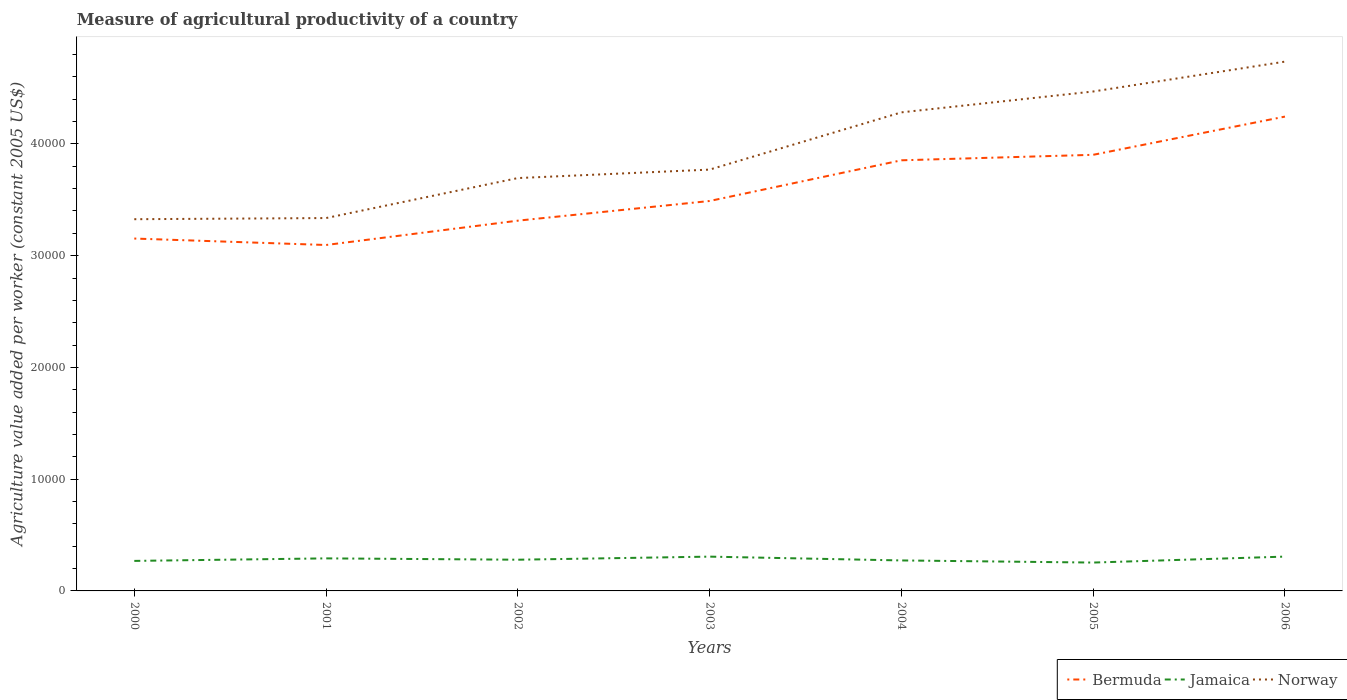How many different coloured lines are there?
Your answer should be very brief. 3. Across all years, what is the maximum measure of agricultural productivity in Jamaica?
Ensure brevity in your answer.  2537.5. In which year was the measure of agricultural productivity in Bermuda maximum?
Give a very brief answer. 2001. What is the total measure of agricultural productivity in Jamaica in the graph?
Give a very brief answer. -533.72. What is the difference between the highest and the second highest measure of agricultural productivity in Bermuda?
Your response must be concise. 1.15e+04. How many years are there in the graph?
Your answer should be very brief. 7. What is the difference between two consecutive major ticks on the Y-axis?
Ensure brevity in your answer.  10000. Are the values on the major ticks of Y-axis written in scientific E-notation?
Make the answer very short. No. Where does the legend appear in the graph?
Provide a succinct answer. Bottom right. How many legend labels are there?
Give a very brief answer. 3. How are the legend labels stacked?
Your response must be concise. Horizontal. What is the title of the graph?
Your response must be concise. Measure of agricultural productivity of a country. Does "Sierra Leone" appear as one of the legend labels in the graph?
Provide a short and direct response. No. What is the label or title of the Y-axis?
Your answer should be very brief. Agriculture value added per worker (constant 2005 US$). What is the Agriculture value added per worker (constant 2005 US$) in Bermuda in 2000?
Give a very brief answer. 3.15e+04. What is the Agriculture value added per worker (constant 2005 US$) in Jamaica in 2000?
Your answer should be very brief. 2686.01. What is the Agriculture value added per worker (constant 2005 US$) in Norway in 2000?
Your response must be concise. 3.33e+04. What is the Agriculture value added per worker (constant 2005 US$) in Bermuda in 2001?
Offer a terse response. 3.10e+04. What is the Agriculture value added per worker (constant 2005 US$) of Jamaica in 2001?
Your response must be concise. 2912.46. What is the Agriculture value added per worker (constant 2005 US$) of Norway in 2001?
Offer a very short reply. 3.34e+04. What is the Agriculture value added per worker (constant 2005 US$) of Bermuda in 2002?
Your answer should be compact. 3.31e+04. What is the Agriculture value added per worker (constant 2005 US$) of Jamaica in 2002?
Provide a succinct answer. 2793.05. What is the Agriculture value added per worker (constant 2005 US$) of Norway in 2002?
Offer a very short reply. 3.69e+04. What is the Agriculture value added per worker (constant 2005 US$) of Bermuda in 2003?
Your answer should be very brief. 3.49e+04. What is the Agriculture value added per worker (constant 2005 US$) of Jamaica in 2003?
Give a very brief answer. 3068.65. What is the Agriculture value added per worker (constant 2005 US$) in Norway in 2003?
Your answer should be very brief. 3.77e+04. What is the Agriculture value added per worker (constant 2005 US$) of Bermuda in 2004?
Offer a terse response. 3.85e+04. What is the Agriculture value added per worker (constant 2005 US$) of Jamaica in 2004?
Make the answer very short. 2727.81. What is the Agriculture value added per worker (constant 2005 US$) of Norway in 2004?
Your response must be concise. 4.28e+04. What is the Agriculture value added per worker (constant 2005 US$) of Bermuda in 2005?
Give a very brief answer. 3.90e+04. What is the Agriculture value added per worker (constant 2005 US$) in Jamaica in 2005?
Keep it short and to the point. 2537.5. What is the Agriculture value added per worker (constant 2005 US$) in Norway in 2005?
Keep it short and to the point. 4.47e+04. What is the Agriculture value added per worker (constant 2005 US$) in Bermuda in 2006?
Ensure brevity in your answer.  4.24e+04. What is the Agriculture value added per worker (constant 2005 US$) in Jamaica in 2006?
Provide a succinct answer. 3071.22. What is the Agriculture value added per worker (constant 2005 US$) of Norway in 2006?
Provide a succinct answer. 4.74e+04. Across all years, what is the maximum Agriculture value added per worker (constant 2005 US$) of Bermuda?
Offer a terse response. 4.24e+04. Across all years, what is the maximum Agriculture value added per worker (constant 2005 US$) of Jamaica?
Ensure brevity in your answer.  3071.22. Across all years, what is the maximum Agriculture value added per worker (constant 2005 US$) of Norway?
Provide a short and direct response. 4.74e+04. Across all years, what is the minimum Agriculture value added per worker (constant 2005 US$) in Bermuda?
Offer a very short reply. 3.10e+04. Across all years, what is the minimum Agriculture value added per worker (constant 2005 US$) in Jamaica?
Give a very brief answer. 2537.5. Across all years, what is the minimum Agriculture value added per worker (constant 2005 US$) in Norway?
Provide a short and direct response. 3.33e+04. What is the total Agriculture value added per worker (constant 2005 US$) in Bermuda in the graph?
Make the answer very short. 2.51e+05. What is the total Agriculture value added per worker (constant 2005 US$) in Jamaica in the graph?
Keep it short and to the point. 1.98e+04. What is the total Agriculture value added per worker (constant 2005 US$) of Norway in the graph?
Your response must be concise. 2.76e+05. What is the difference between the Agriculture value added per worker (constant 2005 US$) of Bermuda in 2000 and that in 2001?
Your answer should be compact. 577.34. What is the difference between the Agriculture value added per worker (constant 2005 US$) in Jamaica in 2000 and that in 2001?
Your answer should be compact. -226.46. What is the difference between the Agriculture value added per worker (constant 2005 US$) in Norway in 2000 and that in 2001?
Give a very brief answer. -102.81. What is the difference between the Agriculture value added per worker (constant 2005 US$) in Bermuda in 2000 and that in 2002?
Provide a succinct answer. -1600.27. What is the difference between the Agriculture value added per worker (constant 2005 US$) of Jamaica in 2000 and that in 2002?
Give a very brief answer. -107.04. What is the difference between the Agriculture value added per worker (constant 2005 US$) in Norway in 2000 and that in 2002?
Your answer should be compact. -3681.59. What is the difference between the Agriculture value added per worker (constant 2005 US$) of Bermuda in 2000 and that in 2003?
Keep it short and to the point. -3360.66. What is the difference between the Agriculture value added per worker (constant 2005 US$) of Jamaica in 2000 and that in 2003?
Make the answer very short. -382.64. What is the difference between the Agriculture value added per worker (constant 2005 US$) in Norway in 2000 and that in 2003?
Make the answer very short. -4439.3. What is the difference between the Agriculture value added per worker (constant 2005 US$) in Bermuda in 2000 and that in 2004?
Give a very brief answer. -7002.21. What is the difference between the Agriculture value added per worker (constant 2005 US$) of Jamaica in 2000 and that in 2004?
Ensure brevity in your answer.  -41.8. What is the difference between the Agriculture value added per worker (constant 2005 US$) of Norway in 2000 and that in 2004?
Provide a short and direct response. -9561.19. What is the difference between the Agriculture value added per worker (constant 2005 US$) of Bermuda in 2000 and that in 2005?
Offer a very short reply. -7493.55. What is the difference between the Agriculture value added per worker (constant 2005 US$) in Jamaica in 2000 and that in 2005?
Make the answer very short. 148.5. What is the difference between the Agriculture value added per worker (constant 2005 US$) of Norway in 2000 and that in 2005?
Provide a succinct answer. -1.14e+04. What is the difference between the Agriculture value added per worker (constant 2005 US$) in Bermuda in 2000 and that in 2006?
Ensure brevity in your answer.  -1.09e+04. What is the difference between the Agriculture value added per worker (constant 2005 US$) in Jamaica in 2000 and that in 2006?
Your answer should be compact. -385.21. What is the difference between the Agriculture value added per worker (constant 2005 US$) of Norway in 2000 and that in 2006?
Offer a terse response. -1.41e+04. What is the difference between the Agriculture value added per worker (constant 2005 US$) of Bermuda in 2001 and that in 2002?
Make the answer very short. -2177.61. What is the difference between the Agriculture value added per worker (constant 2005 US$) of Jamaica in 2001 and that in 2002?
Provide a short and direct response. 119.42. What is the difference between the Agriculture value added per worker (constant 2005 US$) of Norway in 2001 and that in 2002?
Offer a terse response. -3578.77. What is the difference between the Agriculture value added per worker (constant 2005 US$) of Bermuda in 2001 and that in 2003?
Provide a short and direct response. -3938. What is the difference between the Agriculture value added per worker (constant 2005 US$) of Jamaica in 2001 and that in 2003?
Provide a succinct answer. -156.18. What is the difference between the Agriculture value added per worker (constant 2005 US$) in Norway in 2001 and that in 2003?
Your answer should be very brief. -4336.49. What is the difference between the Agriculture value added per worker (constant 2005 US$) of Bermuda in 2001 and that in 2004?
Offer a very short reply. -7579.55. What is the difference between the Agriculture value added per worker (constant 2005 US$) in Jamaica in 2001 and that in 2004?
Your answer should be very brief. 184.66. What is the difference between the Agriculture value added per worker (constant 2005 US$) in Norway in 2001 and that in 2004?
Offer a terse response. -9458.38. What is the difference between the Agriculture value added per worker (constant 2005 US$) in Bermuda in 2001 and that in 2005?
Ensure brevity in your answer.  -8070.89. What is the difference between the Agriculture value added per worker (constant 2005 US$) in Jamaica in 2001 and that in 2005?
Provide a succinct answer. 374.96. What is the difference between the Agriculture value added per worker (constant 2005 US$) of Norway in 2001 and that in 2005?
Ensure brevity in your answer.  -1.13e+04. What is the difference between the Agriculture value added per worker (constant 2005 US$) in Bermuda in 2001 and that in 2006?
Keep it short and to the point. -1.15e+04. What is the difference between the Agriculture value added per worker (constant 2005 US$) in Jamaica in 2001 and that in 2006?
Offer a very short reply. -158.76. What is the difference between the Agriculture value added per worker (constant 2005 US$) in Norway in 2001 and that in 2006?
Offer a terse response. -1.40e+04. What is the difference between the Agriculture value added per worker (constant 2005 US$) in Bermuda in 2002 and that in 2003?
Offer a terse response. -1760.39. What is the difference between the Agriculture value added per worker (constant 2005 US$) in Jamaica in 2002 and that in 2003?
Provide a succinct answer. -275.6. What is the difference between the Agriculture value added per worker (constant 2005 US$) of Norway in 2002 and that in 2003?
Provide a short and direct response. -757.71. What is the difference between the Agriculture value added per worker (constant 2005 US$) in Bermuda in 2002 and that in 2004?
Your answer should be compact. -5401.94. What is the difference between the Agriculture value added per worker (constant 2005 US$) in Jamaica in 2002 and that in 2004?
Keep it short and to the point. 65.24. What is the difference between the Agriculture value added per worker (constant 2005 US$) in Norway in 2002 and that in 2004?
Offer a very short reply. -5879.61. What is the difference between the Agriculture value added per worker (constant 2005 US$) of Bermuda in 2002 and that in 2005?
Keep it short and to the point. -5893.28. What is the difference between the Agriculture value added per worker (constant 2005 US$) of Jamaica in 2002 and that in 2005?
Your answer should be compact. 255.54. What is the difference between the Agriculture value added per worker (constant 2005 US$) in Norway in 2002 and that in 2005?
Give a very brief answer. -7746.68. What is the difference between the Agriculture value added per worker (constant 2005 US$) in Bermuda in 2002 and that in 2006?
Make the answer very short. -9312.49. What is the difference between the Agriculture value added per worker (constant 2005 US$) of Jamaica in 2002 and that in 2006?
Your response must be concise. -278.17. What is the difference between the Agriculture value added per worker (constant 2005 US$) in Norway in 2002 and that in 2006?
Make the answer very short. -1.04e+04. What is the difference between the Agriculture value added per worker (constant 2005 US$) of Bermuda in 2003 and that in 2004?
Make the answer very short. -3641.55. What is the difference between the Agriculture value added per worker (constant 2005 US$) in Jamaica in 2003 and that in 2004?
Provide a succinct answer. 340.84. What is the difference between the Agriculture value added per worker (constant 2005 US$) in Norway in 2003 and that in 2004?
Offer a very short reply. -5121.89. What is the difference between the Agriculture value added per worker (constant 2005 US$) in Bermuda in 2003 and that in 2005?
Your answer should be compact. -4132.89. What is the difference between the Agriculture value added per worker (constant 2005 US$) of Jamaica in 2003 and that in 2005?
Your response must be concise. 531.14. What is the difference between the Agriculture value added per worker (constant 2005 US$) of Norway in 2003 and that in 2005?
Your answer should be very brief. -6988.97. What is the difference between the Agriculture value added per worker (constant 2005 US$) of Bermuda in 2003 and that in 2006?
Make the answer very short. -7552.1. What is the difference between the Agriculture value added per worker (constant 2005 US$) of Jamaica in 2003 and that in 2006?
Keep it short and to the point. -2.57. What is the difference between the Agriculture value added per worker (constant 2005 US$) in Norway in 2003 and that in 2006?
Your answer should be compact. -9661.74. What is the difference between the Agriculture value added per worker (constant 2005 US$) of Bermuda in 2004 and that in 2005?
Offer a very short reply. -491.34. What is the difference between the Agriculture value added per worker (constant 2005 US$) of Jamaica in 2004 and that in 2005?
Your answer should be compact. 190.31. What is the difference between the Agriculture value added per worker (constant 2005 US$) of Norway in 2004 and that in 2005?
Provide a succinct answer. -1867.08. What is the difference between the Agriculture value added per worker (constant 2005 US$) in Bermuda in 2004 and that in 2006?
Make the answer very short. -3910.55. What is the difference between the Agriculture value added per worker (constant 2005 US$) in Jamaica in 2004 and that in 2006?
Provide a short and direct response. -343.41. What is the difference between the Agriculture value added per worker (constant 2005 US$) in Norway in 2004 and that in 2006?
Your answer should be compact. -4539.85. What is the difference between the Agriculture value added per worker (constant 2005 US$) in Bermuda in 2005 and that in 2006?
Your answer should be very brief. -3419.22. What is the difference between the Agriculture value added per worker (constant 2005 US$) of Jamaica in 2005 and that in 2006?
Offer a terse response. -533.72. What is the difference between the Agriculture value added per worker (constant 2005 US$) of Norway in 2005 and that in 2006?
Offer a very short reply. -2672.77. What is the difference between the Agriculture value added per worker (constant 2005 US$) in Bermuda in 2000 and the Agriculture value added per worker (constant 2005 US$) in Jamaica in 2001?
Provide a succinct answer. 2.86e+04. What is the difference between the Agriculture value added per worker (constant 2005 US$) in Bermuda in 2000 and the Agriculture value added per worker (constant 2005 US$) in Norway in 2001?
Offer a very short reply. -1833.43. What is the difference between the Agriculture value added per worker (constant 2005 US$) of Jamaica in 2000 and the Agriculture value added per worker (constant 2005 US$) of Norway in 2001?
Give a very brief answer. -3.07e+04. What is the difference between the Agriculture value added per worker (constant 2005 US$) of Bermuda in 2000 and the Agriculture value added per worker (constant 2005 US$) of Jamaica in 2002?
Provide a short and direct response. 2.87e+04. What is the difference between the Agriculture value added per worker (constant 2005 US$) of Bermuda in 2000 and the Agriculture value added per worker (constant 2005 US$) of Norway in 2002?
Offer a very short reply. -5412.21. What is the difference between the Agriculture value added per worker (constant 2005 US$) in Jamaica in 2000 and the Agriculture value added per worker (constant 2005 US$) in Norway in 2002?
Your response must be concise. -3.43e+04. What is the difference between the Agriculture value added per worker (constant 2005 US$) of Bermuda in 2000 and the Agriculture value added per worker (constant 2005 US$) of Jamaica in 2003?
Offer a very short reply. 2.85e+04. What is the difference between the Agriculture value added per worker (constant 2005 US$) of Bermuda in 2000 and the Agriculture value added per worker (constant 2005 US$) of Norway in 2003?
Your answer should be compact. -6169.92. What is the difference between the Agriculture value added per worker (constant 2005 US$) of Jamaica in 2000 and the Agriculture value added per worker (constant 2005 US$) of Norway in 2003?
Your response must be concise. -3.50e+04. What is the difference between the Agriculture value added per worker (constant 2005 US$) of Bermuda in 2000 and the Agriculture value added per worker (constant 2005 US$) of Jamaica in 2004?
Make the answer very short. 2.88e+04. What is the difference between the Agriculture value added per worker (constant 2005 US$) in Bermuda in 2000 and the Agriculture value added per worker (constant 2005 US$) in Norway in 2004?
Provide a short and direct response. -1.13e+04. What is the difference between the Agriculture value added per worker (constant 2005 US$) of Jamaica in 2000 and the Agriculture value added per worker (constant 2005 US$) of Norway in 2004?
Make the answer very short. -4.01e+04. What is the difference between the Agriculture value added per worker (constant 2005 US$) in Bermuda in 2000 and the Agriculture value added per worker (constant 2005 US$) in Jamaica in 2005?
Your answer should be compact. 2.90e+04. What is the difference between the Agriculture value added per worker (constant 2005 US$) of Bermuda in 2000 and the Agriculture value added per worker (constant 2005 US$) of Norway in 2005?
Offer a very short reply. -1.32e+04. What is the difference between the Agriculture value added per worker (constant 2005 US$) of Jamaica in 2000 and the Agriculture value added per worker (constant 2005 US$) of Norway in 2005?
Offer a terse response. -4.20e+04. What is the difference between the Agriculture value added per worker (constant 2005 US$) of Bermuda in 2000 and the Agriculture value added per worker (constant 2005 US$) of Jamaica in 2006?
Keep it short and to the point. 2.85e+04. What is the difference between the Agriculture value added per worker (constant 2005 US$) in Bermuda in 2000 and the Agriculture value added per worker (constant 2005 US$) in Norway in 2006?
Keep it short and to the point. -1.58e+04. What is the difference between the Agriculture value added per worker (constant 2005 US$) of Jamaica in 2000 and the Agriculture value added per worker (constant 2005 US$) of Norway in 2006?
Give a very brief answer. -4.47e+04. What is the difference between the Agriculture value added per worker (constant 2005 US$) in Bermuda in 2001 and the Agriculture value added per worker (constant 2005 US$) in Jamaica in 2002?
Keep it short and to the point. 2.82e+04. What is the difference between the Agriculture value added per worker (constant 2005 US$) of Bermuda in 2001 and the Agriculture value added per worker (constant 2005 US$) of Norway in 2002?
Offer a terse response. -5989.55. What is the difference between the Agriculture value added per worker (constant 2005 US$) of Jamaica in 2001 and the Agriculture value added per worker (constant 2005 US$) of Norway in 2002?
Keep it short and to the point. -3.40e+04. What is the difference between the Agriculture value added per worker (constant 2005 US$) in Bermuda in 2001 and the Agriculture value added per worker (constant 2005 US$) in Jamaica in 2003?
Keep it short and to the point. 2.79e+04. What is the difference between the Agriculture value added per worker (constant 2005 US$) of Bermuda in 2001 and the Agriculture value added per worker (constant 2005 US$) of Norway in 2003?
Your answer should be very brief. -6747.26. What is the difference between the Agriculture value added per worker (constant 2005 US$) in Jamaica in 2001 and the Agriculture value added per worker (constant 2005 US$) in Norway in 2003?
Your response must be concise. -3.48e+04. What is the difference between the Agriculture value added per worker (constant 2005 US$) of Bermuda in 2001 and the Agriculture value added per worker (constant 2005 US$) of Jamaica in 2004?
Your response must be concise. 2.82e+04. What is the difference between the Agriculture value added per worker (constant 2005 US$) of Bermuda in 2001 and the Agriculture value added per worker (constant 2005 US$) of Norway in 2004?
Your answer should be very brief. -1.19e+04. What is the difference between the Agriculture value added per worker (constant 2005 US$) in Jamaica in 2001 and the Agriculture value added per worker (constant 2005 US$) in Norway in 2004?
Your answer should be compact. -3.99e+04. What is the difference between the Agriculture value added per worker (constant 2005 US$) in Bermuda in 2001 and the Agriculture value added per worker (constant 2005 US$) in Jamaica in 2005?
Your response must be concise. 2.84e+04. What is the difference between the Agriculture value added per worker (constant 2005 US$) in Bermuda in 2001 and the Agriculture value added per worker (constant 2005 US$) in Norway in 2005?
Offer a terse response. -1.37e+04. What is the difference between the Agriculture value added per worker (constant 2005 US$) in Jamaica in 2001 and the Agriculture value added per worker (constant 2005 US$) in Norway in 2005?
Offer a very short reply. -4.18e+04. What is the difference between the Agriculture value added per worker (constant 2005 US$) of Bermuda in 2001 and the Agriculture value added per worker (constant 2005 US$) of Jamaica in 2006?
Offer a terse response. 2.79e+04. What is the difference between the Agriculture value added per worker (constant 2005 US$) in Bermuda in 2001 and the Agriculture value added per worker (constant 2005 US$) in Norway in 2006?
Your response must be concise. -1.64e+04. What is the difference between the Agriculture value added per worker (constant 2005 US$) in Jamaica in 2001 and the Agriculture value added per worker (constant 2005 US$) in Norway in 2006?
Keep it short and to the point. -4.45e+04. What is the difference between the Agriculture value added per worker (constant 2005 US$) in Bermuda in 2002 and the Agriculture value added per worker (constant 2005 US$) in Jamaica in 2003?
Offer a terse response. 3.01e+04. What is the difference between the Agriculture value added per worker (constant 2005 US$) of Bermuda in 2002 and the Agriculture value added per worker (constant 2005 US$) of Norway in 2003?
Keep it short and to the point. -4569.65. What is the difference between the Agriculture value added per worker (constant 2005 US$) of Jamaica in 2002 and the Agriculture value added per worker (constant 2005 US$) of Norway in 2003?
Offer a very short reply. -3.49e+04. What is the difference between the Agriculture value added per worker (constant 2005 US$) of Bermuda in 2002 and the Agriculture value added per worker (constant 2005 US$) of Jamaica in 2004?
Provide a short and direct response. 3.04e+04. What is the difference between the Agriculture value added per worker (constant 2005 US$) in Bermuda in 2002 and the Agriculture value added per worker (constant 2005 US$) in Norway in 2004?
Your answer should be very brief. -9691.54. What is the difference between the Agriculture value added per worker (constant 2005 US$) of Jamaica in 2002 and the Agriculture value added per worker (constant 2005 US$) of Norway in 2004?
Your answer should be compact. -4.00e+04. What is the difference between the Agriculture value added per worker (constant 2005 US$) in Bermuda in 2002 and the Agriculture value added per worker (constant 2005 US$) in Jamaica in 2005?
Your answer should be compact. 3.06e+04. What is the difference between the Agriculture value added per worker (constant 2005 US$) in Bermuda in 2002 and the Agriculture value added per worker (constant 2005 US$) in Norway in 2005?
Ensure brevity in your answer.  -1.16e+04. What is the difference between the Agriculture value added per worker (constant 2005 US$) of Jamaica in 2002 and the Agriculture value added per worker (constant 2005 US$) of Norway in 2005?
Your response must be concise. -4.19e+04. What is the difference between the Agriculture value added per worker (constant 2005 US$) of Bermuda in 2002 and the Agriculture value added per worker (constant 2005 US$) of Jamaica in 2006?
Your answer should be very brief. 3.01e+04. What is the difference between the Agriculture value added per worker (constant 2005 US$) of Bermuda in 2002 and the Agriculture value added per worker (constant 2005 US$) of Norway in 2006?
Ensure brevity in your answer.  -1.42e+04. What is the difference between the Agriculture value added per worker (constant 2005 US$) of Jamaica in 2002 and the Agriculture value added per worker (constant 2005 US$) of Norway in 2006?
Offer a very short reply. -4.46e+04. What is the difference between the Agriculture value added per worker (constant 2005 US$) in Bermuda in 2003 and the Agriculture value added per worker (constant 2005 US$) in Jamaica in 2004?
Provide a succinct answer. 3.22e+04. What is the difference between the Agriculture value added per worker (constant 2005 US$) in Bermuda in 2003 and the Agriculture value added per worker (constant 2005 US$) in Norway in 2004?
Provide a succinct answer. -7931.15. What is the difference between the Agriculture value added per worker (constant 2005 US$) in Jamaica in 2003 and the Agriculture value added per worker (constant 2005 US$) in Norway in 2004?
Provide a succinct answer. -3.98e+04. What is the difference between the Agriculture value added per worker (constant 2005 US$) of Bermuda in 2003 and the Agriculture value added per worker (constant 2005 US$) of Jamaica in 2005?
Provide a short and direct response. 3.24e+04. What is the difference between the Agriculture value added per worker (constant 2005 US$) of Bermuda in 2003 and the Agriculture value added per worker (constant 2005 US$) of Norway in 2005?
Provide a succinct answer. -9798.23. What is the difference between the Agriculture value added per worker (constant 2005 US$) of Jamaica in 2003 and the Agriculture value added per worker (constant 2005 US$) of Norway in 2005?
Make the answer very short. -4.16e+04. What is the difference between the Agriculture value added per worker (constant 2005 US$) of Bermuda in 2003 and the Agriculture value added per worker (constant 2005 US$) of Jamaica in 2006?
Give a very brief answer. 3.18e+04. What is the difference between the Agriculture value added per worker (constant 2005 US$) in Bermuda in 2003 and the Agriculture value added per worker (constant 2005 US$) in Norway in 2006?
Your answer should be compact. -1.25e+04. What is the difference between the Agriculture value added per worker (constant 2005 US$) in Jamaica in 2003 and the Agriculture value added per worker (constant 2005 US$) in Norway in 2006?
Your answer should be compact. -4.43e+04. What is the difference between the Agriculture value added per worker (constant 2005 US$) of Bermuda in 2004 and the Agriculture value added per worker (constant 2005 US$) of Jamaica in 2005?
Your answer should be very brief. 3.60e+04. What is the difference between the Agriculture value added per worker (constant 2005 US$) of Bermuda in 2004 and the Agriculture value added per worker (constant 2005 US$) of Norway in 2005?
Provide a succinct answer. -6156.68. What is the difference between the Agriculture value added per worker (constant 2005 US$) in Jamaica in 2004 and the Agriculture value added per worker (constant 2005 US$) in Norway in 2005?
Your answer should be very brief. -4.20e+04. What is the difference between the Agriculture value added per worker (constant 2005 US$) in Bermuda in 2004 and the Agriculture value added per worker (constant 2005 US$) in Jamaica in 2006?
Offer a very short reply. 3.55e+04. What is the difference between the Agriculture value added per worker (constant 2005 US$) in Bermuda in 2004 and the Agriculture value added per worker (constant 2005 US$) in Norway in 2006?
Give a very brief answer. -8829.45. What is the difference between the Agriculture value added per worker (constant 2005 US$) of Jamaica in 2004 and the Agriculture value added per worker (constant 2005 US$) of Norway in 2006?
Offer a very short reply. -4.46e+04. What is the difference between the Agriculture value added per worker (constant 2005 US$) in Bermuda in 2005 and the Agriculture value added per worker (constant 2005 US$) in Jamaica in 2006?
Your answer should be compact. 3.60e+04. What is the difference between the Agriculture value added per worker (constant 2005 US$) in Bermuda in 2005 and the Agriculture value added per worker (constant 2005 US$) in Norway in 2006?
Your answer should be compact. -8338.11. What is the difference between the Agriculture value added per worker (constant 2005 US$) of Jamaica in 2005 and the Agriculture value added per worker (constant 2005 US$) of Norway in 2006?
Make the answer very short. -4.48e+04. What is the average Agriculture value added per worker (constant 2005 US$) in Bermuda per year?
Keep it short and to the point. 3.58e+04. What is the average Agriculture value added per worker (constant 2005 US$) of Jamaica per year?
Your answer should be compact. 2828.1. What is the average Agriculture value added per worker (constant 2005 US$) of Norway per year?
Offer a terse response. 3.94e+04. In the year 2000, what is the difference between the Agriculture value added per worker (constant 2005 US$) of Bermuda and Agriculture value added per worker (constant 2005 US$) of Jamaica?
Your response must be concise. 2.88e+04. In the year 2000, what is the difference between the Agriculture value added per worker (constant 2005 US$) of Bermuda and Agriculture value added per worker (constant 2005 US$) of Norway?
Provide a short and direct response. -1730.62. In the year 2000, what is the difference between the Agriculture value added per worker (constant 2005 US$) of Jamaica and Agriculture value added per worker (constant 2005 US$) of Norway?
Your response must be concise. -3.06e+04. In the year 2001, what is the difference between the Agriculture value added per worker (constant 2005 US$) in Bermuda and Agriculture value added per worker (constant 2005 US$) in Jamaica?
Give a very brief answer. 2.80e+04. In the year 2001, what is the difference between the Agriculture value added per worker (constant 2005 US$) of Bermuda and Agriculture value added per worker (constant 2005 US$) of Norway?
Your response must be concise. -2410.77. In the year 2001, what is the difference between the Agriculture value added per worker (constant 2005 US$) of Jamaica and Agriculture value added per worker (constant 2005 US$) of Norway?
Provide a succinct answer. -3.05e+04. In the year 2002, what is the difference between the Agriculture value added per worker (constant 2005 US$) of Bermuda and Agriculture value added per worker (constant 2005 US$) of Jamaica?
Make the answer very short. 3.03e+04. In the year 2002, what is the difference between the Agriculture value added per worker (constant 2005 US$) of Bermuda and Agriculture value added per worker (constant 2005 US$) of Norway?
Your answer should be compact. -3811.94. In the year 2002, what is the difference between the Agriculture value added per worker (constant 2005 US$) of Jamaica and Agriculture value added per worker (constant 2005 US$) of Norway?
Your answer should be very brief. -3.42e+04. In the year 2003, what is the difference between the Agriculture value added per worker (constant 2005 US$) of Bermuda and Agriculture value added per worker (constant 2005 US$) of Jamaica?
Give a very brief answer. 3.18e+04. In the year 2003, what is the difference between the Agriculture value added per worker (constant 2005 US$) in Bermuda and Agriculture value added per worker (constant 2005 US$) in Norway?
Give a very brief answer. -2809.26. In the year 2003, what is the difference between the Agriculture value added per worker (constant 2005 US$) of Jamaica and Agriculture value added per worker (constant 2005 US$) of Norway?
Offer a very short reply. -3.46e+04. In the year 2004, what is the difference between the Agriculture value added per worker (constant 2005 US$) in Bermuda and Agriculture value added per worker (constant 2005 US$) in Jamaica?
Offer a terse response. 3.58e+04. In the year 2004, what is the difference between the Agriculture value added per worker (constant 2005 US$) in Bermuda and Agriculture value added per worker (constant 2005 US$) in Norway?
Offer a very short reply. -4289.6. In the year 2004, what is the difference between the Agriculture value added per worker (constant 2005 US$) of Jamaica and Agriculture value added per worker (constant 2005 US$) of Norway?
Ensure brevity in your answer.  -4.01e+04. In the year 2005, what is the difference between the Agriculture value added per worker (constant 2005 US$) in Bermuda and Agriculture value added per worker (constant 2005 US$) in Jamaica?
Your response must be concise. 3.65e+04. In the year 2005, what is the difference between the Agriculture value added per worker (constant 2005 US$) in Bermuda and Agriculture value added per worker (constant 2005 US$) in Norway?
Your answer should be compact. -5665.34. In the year 2005, what is the difference between the Agriculture value added per worker (constant 2005 US$) in Jamaica and Agriculture value added per worker (constant 2005 US$) in Norway?
Give a very brief answer. -4.22e+04. In the year 2006, what is the difference between the Agriculture value added per worker (constant 2005 US$) of Bermuda and Agriculture value added per worker (constant 2005 US$) of Jamaica?
Provide a short and direct response. 3.94e+04. In the year 2006, what is the difference between the Agriculture value added per worker (constant 2005 US$) of Bermuda and Agriculture value added per worker (constant 2005 US$) of Norway?
Provide a succinct answer. -4918.89. In the year 2006, what is the difference between the Agriculture value added per worker (constant 2005 US$) of Jamaica and Agriculture value added per worker (constant 2005 US$) of Norway?
Offer a very short reply. -4.43e+04. What is the ratio of the Agriculture value added per worker (constant 2005 US$) of Bermuda in 2000 to that in 2001?
Ensure brevity in your answer.  1.02. What is the ratio of the Agriculture value added per worker (constant 2005 US$) in Jamaica in 2000 to that in 2001?
Your response must be concise. 0.92. What is the ratio of the Agriculture value added per worker (constant 2005 US$) in Bermuda in 2000 to that in 2002?
Keep it short and to the point. 0.95. What is the ratio of the Agriculture value added per worker (constant 2005 US$) of Jamaica in 2000 to that in 2002?
Offer a very short reply. 0.96. What is the ratio of the Agriculture value added per worker (constant 2005 US$) in Norway in 2000 to that in 2002?
Your response must be concise. 0.9. What is the ratio of the Agriculture value added per worker (constant 2005 US$) of Bermuda in 2000 to that in 2003?
Your answer should be compact. 0.9. What is the ratio of the Agriculture value added per worker (constant 2005 US$) in Jamaica in 2000 to that in 2003?
Offer a terse response. 0.88. What is the ratio of the Agriculture value added per worker (constant 2005 US$) in Norway in 2000 to that in 2003?
Keep it short and to the point. 0.88. What is the ratio of the Agriculture value added per worker (constant 2005 US$) in Bermuda in 2000 to that in 2004?
Offer a very short reply. 0.82. What is the ratio of the Agriculture value added per worker (constant 2005 US$) of Jamaica in 2000 to that in 2004?
Your response must be concise. 0.98. What is the ratio of the Agriculture value added per worker (constant 2005 US$) in Norway in 2000 to that in 2004?
Provide a short and direct response. 0.78. What is the ratio of the Agriculture value added per worker (constant 2005 US$) of Bermuda in 2000 to that in 2005?
Your response must be concise. 0.81. What is the ratio of the Agriculture value added per worker (constant 2005 US$) in Jamaica in 2000 to that in 2005?
Provide a short and direct response. 1.06. What is the ratio of the Agriculture value added per worker (constant 2005 US$) in Norway in 2000 to that in 2005?
Your answer should be very brief. 0.74. What is the ratio of the Agriculture value added per worker (constant 2005 US$) of Bermuda in 2000 to that in 2006?
Ensure brevity in your answer.  0.74. What is the ratio of the Agriculture value added per worker (constant 2005 US$) of Jamaica in 2000 to that in 2006?
Your answer should be very brief. 0.87. What is the ratio of the Agriculture value added per worker (constant 2005 US$) in Norway in 2000 to that in 2006?
Keep it short and to the point. 0.7. What is the ratio of the Agriculture value added per worker (constant 2005 US$) in Bermuda in 2001 to that in 2002?
Provide a succinct answer. 0.93. What is the ratio of the Agriculture value added per worker (constant 2005 US$) of Jamaica in 2001 to that in 2002?
Provide a short and direct response. 1.04. What is the ratio of the Agriculture value added per worker (constant 2005 US$) of Norway in 2001 to that in 2002?
Offer a terse response. 0.9. What is the ratio of the Agriculture value added per worker (constant 2005 US$) of Bermuda in 2001 to that in 2003?
Keep it short and to the point. 0.89. What is the ratio of the Agriculture value added per worker (constant 2005 US$) in Jamaica in 2001 to that in 2003?
Your response must be concise. 0.95. What is the ratio of the Agriculture value added per worker (constant 2005 US$) in Norway in 2001 to that in 2003?
Keep it short and to the point. 0.89. What is the ratio of the Agriculture value added per worker (constant 2005 US$) in Bermuda in 2001 to that in 2004?
Keep it short and to the point. 0.8. What is the ratio of the Agriculture value added per worker (constant 2005 US$) in Jamaica in 2001 to that in 2004?
Offer a very short reply. 1.07. What is the ratio of the Agriculture value added per worker (constant 2005 US$) in Norway in 2001 to that in 2004?
Your response must be concise. 0.78. What is the ratio of the Agriculture value added per worker (constant 2005 US$) of Bermuda in 2001 to that in 2005?
Your answer should be very brief. 0.79. What is the ratio of the Agriculture value added per worker (constant 2005 US$) in Jamaica in 2001 to that in 2005?
Your response must be concise. 1.15. What is the ratio of the Agriculture value added per worker (constant 2005 US$) in Norway in 2001 to that in 2005?
Offer a very short reply. 0.75. What is the ratio of the Agriculture value added per worker (constant 2005 US$) of Bermuda in 2001 to that in 2006?
Your answer should be compact. 0.73. What is the ratio of the Agriculture value added per worker (constant 2005 US$) of Jamaica in 2001 to that in 2006?
Your response must be concise. 0.95. What is the ratio of the Agriculture value added per worker (constant 2005 US$) in Norway in 2001 to that in 2006?
Give a very brief answer. 0.7. What is the ratio of the Agriculture value added per worker (constant 2005 US$) of Bermuda in 2002 to that in 2003?
Your response must be concise. 0.95. What is the ratio of the Agriculture value added per worker (constant 2005 US$) of Jamaica in 2002 to that in 2003?
Your response must be concise. 0.91. What is the ratio of the Agriculture value added per worker (constant 2005 US$) of Norway in 2002 to that in 2003?
Your answer should be compact. 0.98. What is the ratio of the Agriculture value added per worker (constant 2005 US$) in Bermuda in 2002 to that in 2004?
Offer a terse response. 0.86. What is the ratio of the Agriculture value added per worker (constant 2005 US$) of Jamaica in 2002 to that in 2004?
Provide a succinct answer. 1.02. What is the ratio of the Agriculture value added per worker (constant 2005 US$) in Norway in 2002 to that in 2004?
Offer a terse response. 0.86. What is the ratio of the Agriculture value added per worker (constant 2005 US$) of Bermuda in 2002 to that in 2005?
Your answer should be compact. 0.85. What is the ratio of the Agriculture value added per worker (constant 2005 US$) in Jamaica in 2002 to that in 2005?
Provide a short and direct response. 1.1. What is the ratio of the Agriculture value added per worker (constant 2005 US$) of Norway in 2002 to that in 2005?
Your answer should be compact. 0.83. What is the ratio of the Agriculture value added per worker (constant 2005 US$) in Bermuda in 2002 to that in 2006?
Keep it short and to the point. 0.78. What is the ratio of the Agriculture value added per worker (constant 2005 US$) of Jamaica in 2002 to that in 2006?
Ensure brevity in your answer.  0.91. What is the ratio of the Agriculture value added per worker (constant 2005 US$) of Norway in 2002 to that in 2006?
Provide a short and direct response. 0.78. What is the ratio of the Agriculture value added per worker (constant 2005 US$) of Bermuda in 2003 to that in 2004?
Offer a very short reply. 0.91. What is the ratio of the Agriculture value added per worker (constant 2005 US$) in Jamaica in 2003 to that in 2004?
Your answer should be very brief. 1.12. What is the ratio of the Agriculture value added per worker (constant 2005 US$) in Norway in 2003 to that in 2004?
Give a very brief answer. 0.88. What is the ratio of the Agriculture value added per worker (constant 2005 US$) in Bermuda in 2003 to that in 2005?
Your answer should be compact. 0.89. What is the ratio of the Agriculture value added per worker (constant 2005 US$) of Jamaica in 2003 to that in 2005?
Your answer should be compact. 1.21. What is the ratio of the Agriculture value added per worker (constant 2005 US$) in Norway in 2003 to that in 2005?
Your answer should be compact. 0.84. What is the ratio of the Agriculture value added per worker (constant 2005 US$) of Bermuda in 2003 to that in 2006?
Provide a succinct answer. 0.82. What is the ratio of the Agriculture value added per worker (constant 2005 US$) of Jamaica in 2003 to that in 2006?
Provide a short and direct response. 1. What is the ratio of the Agriculture value added per worker (constant 2005 US$) of Norway in 2003 to that in 2006?
Make the answer very short. 0.8. What is the ratio of the Agriculture value added per worker (constant 2005 US$) in Bermuda in 2004 to that in 2005?
Keep it short and to the point. 0.99. What is the ratio of the Agriculture value added per worker (constant 2005 US$) of Jamaica in 2004 to that in 2005?
Your answer should be compact. 1.07. What is the ratio of the Agriculture value added per worker (constant 2005 US$) of Norway in 2004 to that in 2005?
Provide a succinct answer. 0.96. What is the ratio of the Agriculture value added per worker (constant 2005 US$) of Bermuda in 2004 to that in 2006?
Ensure brevity in your answer.  0.91. What is the ratio of the Agriculture value added per worker (constant 2005 US$) in Jamaica in 2004 to that in 2006?
Keep it short and to the point. 0.89. What is the ratio of the Agriculture value added per worker (constant 2005 US$) of Norway in 2004 to that in 2006?
Your answer should be compact. 0.9. What is the ratio of the Agriculture value added per worker (constant 2005 US$) of Bermuda in 2005 to that in 2006?
Provide a short and direct response. 0.92. What is the ratio of the Agriculture value added per worker (constant 2005 US$) of Jamaica in 2005 to that in 2006?
Provide a succinct answer. 0.83. What is the ratio of the Agriculture value added per worker (constant 2005 US$) of Norway in 2005 to that in 2006?
Your answer should be very brief. 0.94. What is the difference between the highest and the second highest Agriculture value added per worker (constant 2005 US$) in Bermuda?
Your answer should be very brief. 3419.22. What is the difference between the highest and the second highest Agriculture value added per worker (constant 2005 US$) in Jamaica?
Provide a short and direct response. 2.57. What is the difference between the highest and the second highest Agriculture value added per worker (constant 2005 US$) in Norway?
Offer a very short reply. 2672.77. What is the difference between the highest and the lowest Agriculture value added per worker (constant 2005 US$) in Bermuda?
Give a very brief answer. 1.15e+04. What is the difference between the highest and the lowest Agriculture value added per worker (constant 2005 US$) of Jamaica?
Ensure brevity in your answer.  533.72. What is the difference between the highest and the lowest Agriculture value added per worker (constant 2005 US$) of Norway?
Make the answer very short. 1.41e+04. 